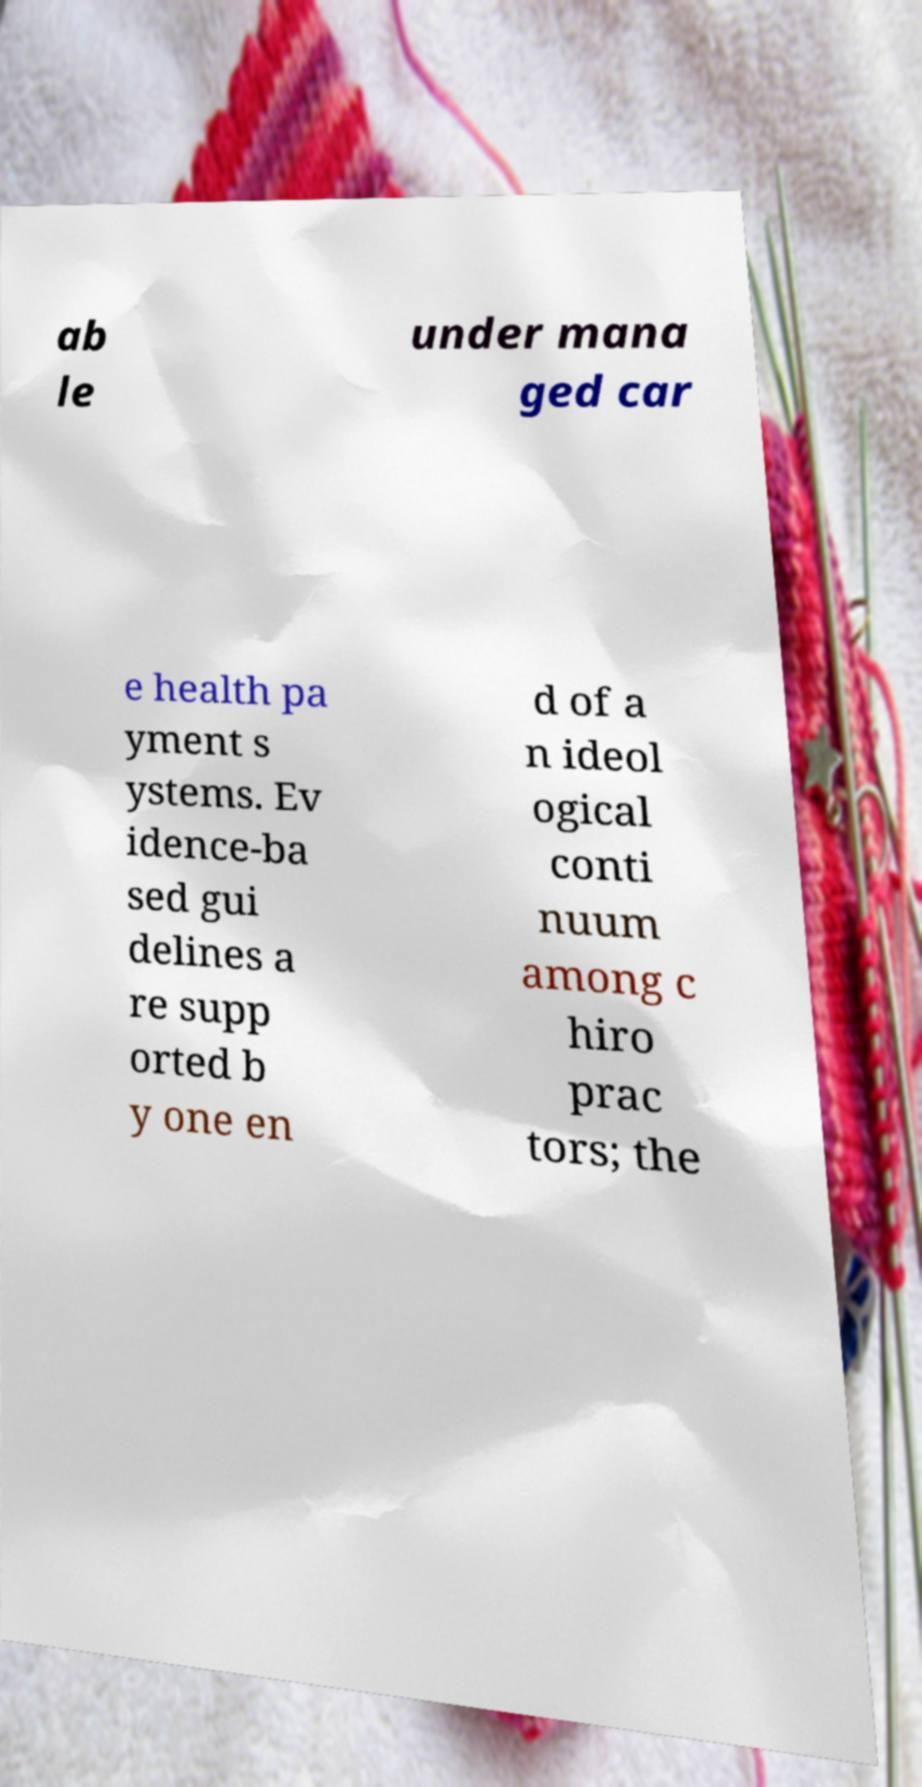Could you assist in decoding the text presented in this image and type it out clearly? ab le under mana ged car e health pa yment s ystems. Ev idence-ba sed gui delines a re supp orted b y one en d of a n ideol ogical conti nuum among c hiro prac tors; the 